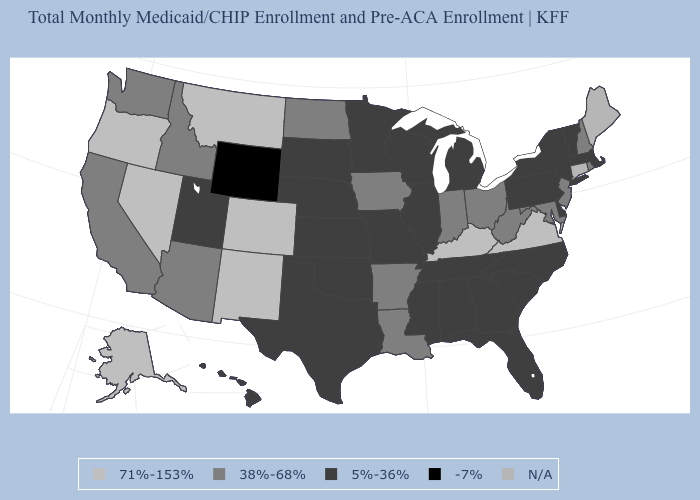What is the value of Colorado?
Give a very brief answer. 71%-153%. What is the value of Nebraska?
Short answer required. 5%-36%. What is the value of New York?
Be succinct. 5%-36%. Name the states that have a value in the range -7%?
Write a very short answer. Wyoming. Does Nevada have the highest value in the West?
Keep it brief. Yes. Name the states that have a value in the range -7%?
Quick response, please. Wyoming. Name the states that have a value in the range -7%?
Be succinct. Wyoming. What is the value of Ohio?
Short answer required. 38%-68%. Which states have the highest value in the USA?
Give a very brief answer. Alaska, Colorado, Kentucky, Montana, Nevada, New Mexico, Oregon, Virginia. Name the states that have a value in the range 38%-68%?
Short answer required. Arizona, Arkansas, California, Idaho, Indiana, Iowa, Louisiana, Maryland, New Hampshire, New Jersey, North Dakota, Ohio, Rhode Island, Washington, West Virginia. What is the value of Wyoming?
Quick response, please. -7%. Name the states that have a value in the range 5%-36%?
Be succinct. Alabama, Delaware, Florida, Georgia, Hawaii, Illinois, Kansas, Massachusetts, Michigan, Minnesota, Mississippi, Missouri, Nebraska, New York, North Carolina, Oklahoma, Pennsylvania, South Carolina, South Dakota, Tennessee, Texas, Utah, Vermont, Wisconsin. Name the states that have a value in the range -7%?
Concise answer only. Wyoming. What is the value of Vermont?
Quick response, please. 5%-36%. Name the states that have a value in the range -7%?
Keep it brief. Wyoming. 